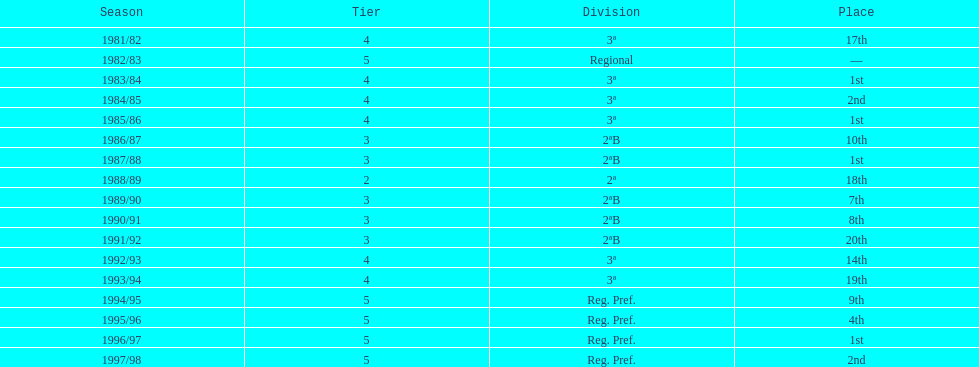What year has no place indicated? 1982/83. 